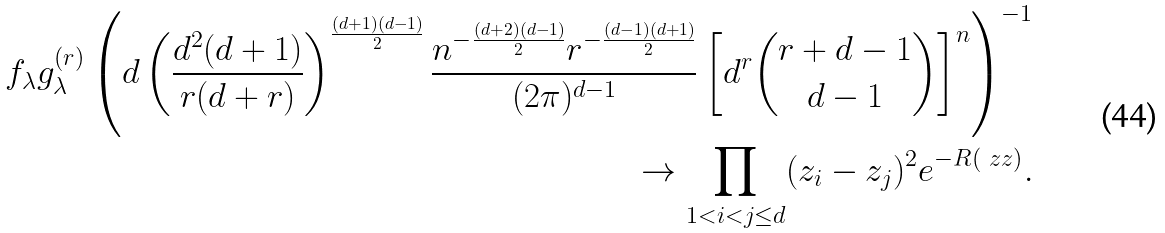Convert formula to latex. <formula><loc_0><loc_0><loc_500><loc_500>f _ { \lambda } g _ { \lambda } ^ { ( r ) } \left ( d \left ( \frac { d ^ { 2 } ( d + 1 ) } { r ( d + r ) } \right ) ^ { \frac { ( d + 1 ) ( d - 1 ) } { 2 } } \frac { n ^ { - \frac { ( d + 2 ) ( d - 1 ) } { 2 } } r ^ { - \frac { ( d - 1 ) ( d + 1 ) } { 2 } } } { ( 2 \pi ) ^ { d - 1 } } \left [ d ^ { r } { r + d - 1 \choose d - 1 } \right ] ^ { n } \right ) ^ { - 1 } \\ \rightarrow \prod _ { 1 < i < j \leq d } ( z _ { i } - z _ { j } ) ^ { 2 } e ^ { - R ( \ z z ) } .</formula> 